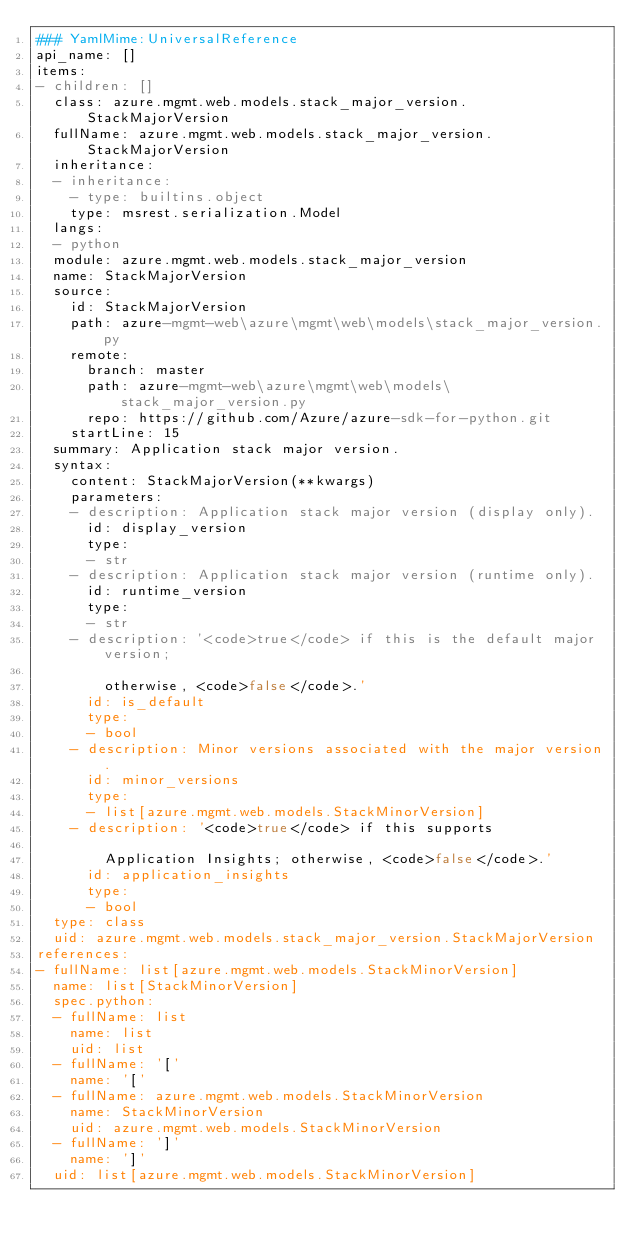Convert code to text. <code><loc_0><loc_0><loc_500><loc_500><_YAML_>### YamlMime:UniversalReference
api_name: []
items:
- children: []
  class: azure.mgmt.web.models.stack_major_version.StackMajorVersion
  fullName: azure.mgmt.web.models.stack_major_version.StackMajorVersion
  inheritance:
  - inheritance:
    - type: builtins.object
    type: msrest.serialization.Model
  langs:
  - python
  module: azure.mgmt.web.models.stack_major_version
  name: StackMajorVersion
  source:
    id: StackMajorVersion
    path: azure-mgmt-web\azure\mgmt\web\models\stack_major_version.py
    remote:
      branch: master
      path: azure-mgmt-web\azure\mgmt\web\models\stack_major_version.py
      repo: https://github.com/Azure/azure-sdk-for-python.git
    startLine: 15
  summary: Application stack major version.
  syntax:
    content: StackMajorVersion(**kwargs)
    parameters:
    - description: Application stack major version (display only).
      id: display_version
      type:
      - str
    - description: Application stack major version (runtime only).
      id: runtime_version
      type:
      - str
    - description: '<code>true</code> if this is the default major version;

        otherwise, <code>false</code>.'
      id: is_default
      type:
      - bool
    - description: Minor versions associated with the major version.
      id: minor_versions
      type:
      - list[azure.mgmt.web.models.StackMinorVersion]
    - description: '<code>true</code> if this supports

        Application Insights; otherwise, <code>false</code>.'
      id: application_insights
      type:
      - bool
  type: class
  uid: azure.mgmt.web.models.stack_major_version.StackMajorVersion
references:
- fullName: list[azure.mgmt.web.models.StackMinorVersion]
  name: list[StackMinorVersion]
  spec.python:
  - fullName: list
    name: list
    uid: list
  - fullName: '['
    name: '['
  - fullName: azure.mgmt.web.models.StackMinorVersion
    name: StackMinorVersion
    uid: azure.mgmt.web.models.StackMinorVersion
  - fullName: ']'
    name: ']'
  uid: list[azure.mgmt.web.models.StackMinorVersion]
</code> 